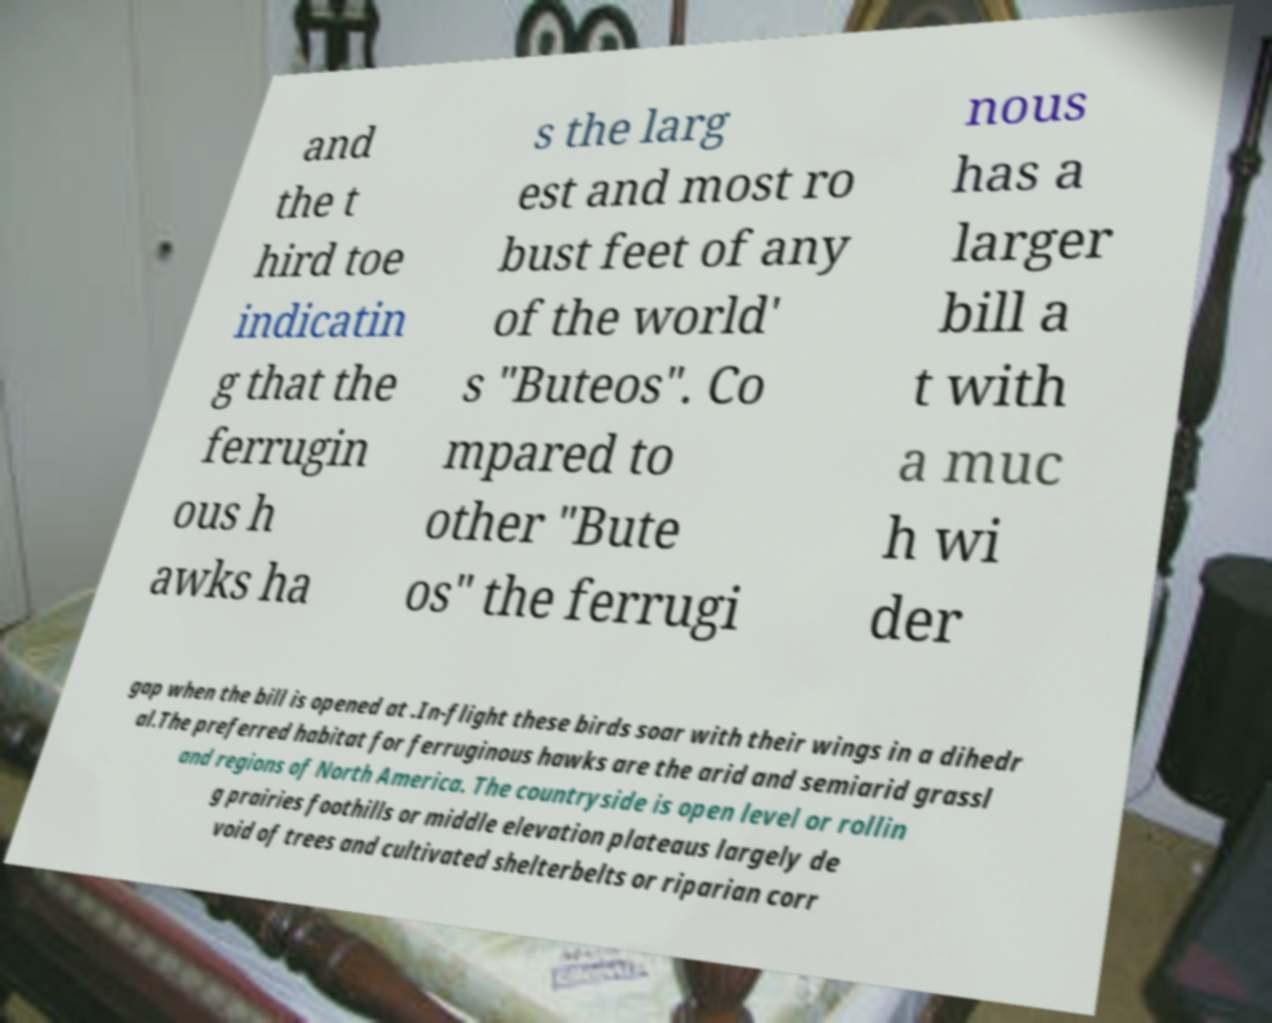There's text embedded in this image that I need extracted. Can you transcribe it verbatim? and the t hird toe indicatin g that the ferrugin ous h awks ha s the larg est and most ro bust feet of any of the world' s "Buteos". Co mpared to other "Bute os" the ferrugi nous has a larger bill a t with a muc h wi der gap when the bill is opened at .In-flight these birds soar with their wings in a dihedr al.The preferred habitat for ferruginous hawks are the arid and semiarid grassl and regions of North America. The countryside is open level or rollin g prairies foothills or middle elevation plateaus largely de void of trees and cultivated shelterbelts or riparian corr 